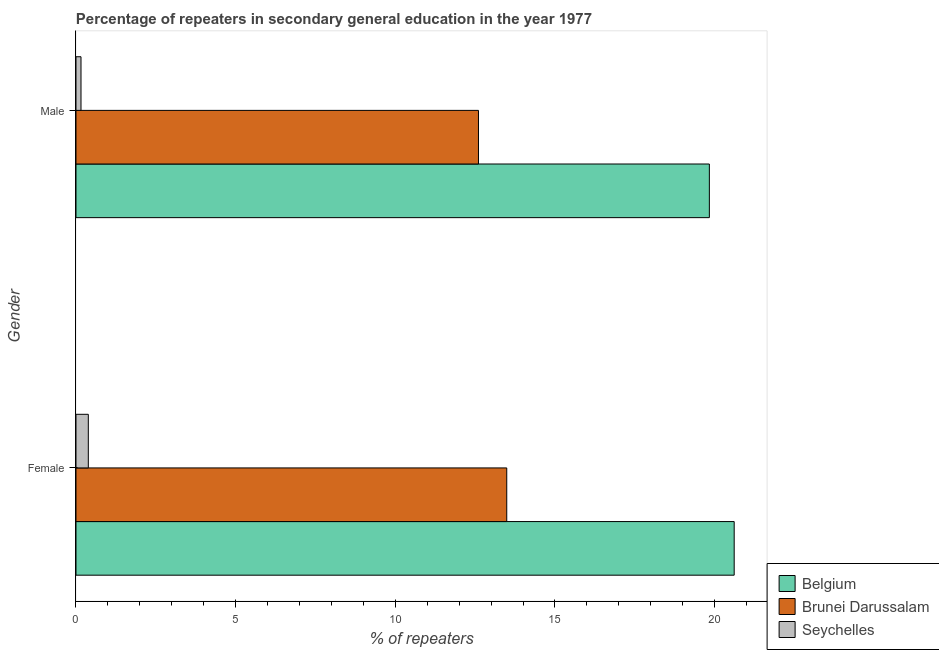How many groups of bars are there?
Your answer should be very brief. 2. Are the number of bars on each tick of the Y-axis equal?
Offer a terse response. Yes. How many bars are there on the 2nd tick from the top?
Ensure brevity in your answer.  3. How many bars are there on the 1st tick from the bottom?
Your answer should be compact. 3. What is the label of the 2nd group of bars from the top?
Offer a terse response. Female. What is the percentage of female repeaters in Belgium?
Offer a very short reply. 20.61. Across all countries, what is the maximum percentage of female repeaters?
Your answer should be very brief. 20.61. Across all countries, what is the minimum percentage of male repeaters?
Your answer should be compact. 0.16. In which country was the percentage of female repeaters maximum?
Give a very brief answer. Belgium. In which country was the percentage of female repeaters minimum?
Your response must be concise. Seychelles. What is the total percentage of male repeaters in the graph?
Provide a short and direct response. 32.6. What is the difference between the percentage of female repeaters in Seychelles and that in Brunei Darussalam?
Give a very brief answer. -13.1. What is the difference between the percentage of male repeaters in Seychelles and the percentage of female repeaters in Brunei Darussalam?
Offer a terse response. -13.33. What is the average percentage of male repeaters per country?
Give a very brief answer. 10.87. What is the difference between the percentage of male repeaters and percentage of female repeaters in Belgium?
Give a very brief answer. -0.78. In how many countries, is the percentage of male repeaters greater than 1 %?
Your answer should be compact. 2. What is the ratio of the percentage of female repeaters in Belgium to that in Seychelles?
Your response must be concise. 53.41. Is the percentage of male repeaters in Seychelles less than that in Brunei Darussalam?
Your answer should be compact. Yes. In how many countries, is the percentage of male repeaters greater than the average percentage of male repeaters taken over all countries?
Your response must be concise. 2. What does the 2nd bar from the top in Female represents?
Your answer should be very brief. Brunei Darussalam. What does the 3rd bar from the bottom in Male represents?
Ensure brevity in your answer.  Seychelles. How many bars are there?
Give a very brief answer. 6. Are all the bars in the graph horizontal?
Your answer should be compact. Yes. How many countries are there in the graph?
Offer a terse response. 3. Does the graph contain any zero values?
Your answer should be very brief. No. Does the graph contain grids?
Your answer should be compact. No. Where does the legend appear in the graph?
Keep it short and to the point. Bottom right. How many legend labels are there?
Your response must be concise. 3. What is the title of the graph?
Provide a short and direct response. Percentage of repeaters in secondary general education in the year 1977. Does "Greenland" appear as one of the legend labels in the graph?
Make the answer very short. No. What is the label or title of the X-axis?
Provide a short and direct response. % of repeaters. What is the label or title of the Y-axis?
Offer a terse response. Gender. What is the % of repeaters in Belgium in Female?
Make the answer very short. 20.61. What is the % of repeaters in Brunei Darussalam in Female?
Provide a short and direct response. 13.49. What is the % of repeaters of Seychelles in Female?
Provide a succinct answer. 0.39. What is the % of repeaters in Belgium in Male?
Your answer should be very brief. 19.83. What is the % of repeaters in Brunei Darussalam in Male?
Give a very brief answer. 12.6. What is the % of repeaters in Seychelles in Male?
Your answer should be compact. 0.16. Across all Gender, what is the maximum % of repeaters of Belgium?
Ensure brevity in your answer.  20.61. Across all Gender, what is the maximum % of repeaters of Brunei Darussalam?
Ensure brevity in your answer.  13.49. Across all Gender, what is the maximum % of repeaters of Seychelles?
Make the answer very short. 0.39. Across all Gender, what is the minimum % of repeaters of Belgium?
Provide a succinct answer. 19.83. Across all Gender, what is the minimum % of repeaters of Brunei Darussalam?
Make the answer very short. 12.6. Across all Gender, what is the minimum % of repeaters of Seychelles?
Provide a succinct answer. 0.16. What is the total % of repeaters of Belgium in the graph?
Offer a very short reply. 40.45. What is the total % of repeaters of Brunei Darussalam in the graph?
Your answer should be compact. 26.09. What is the total % of repeaters of Seychelles in the graph?
Ensure brevity in your answer.  0.54. What is the difference between the % of repeaters in Belgium in Female and that in Male?
Make the answer very short. 0.78. What is the difference between the % of repeaters of Brunei Darussalam in Female and that in Male?
Offer a terse response. 0.89. What is the difference between the % of repeaters of Seychelles in Female and that in Male?
Provide a succinct answer. 0.23. What is the difference between the % of repeaters in Belgium in Female and the % of repeaters in Brunei Darussalam in Male?
Your response must be concise. 8.01. What is the difference between the % of repeaters of Belgium in Female and the % of repeaters of Seychelles in Male?
Your answer should be very brief. 20.46. What is the difference between the % of repeaters of Brunei Darussalam in Female and the % of repeaters of Seychelles in Male?
Ensure brevity in your answer.  13.33. What is the average % of repeaters of Belgium per Gender?
Give a very brief answer. 20.22. What is the average % of repeaters of Brunei Darussalam per Gender?
Offer a very short reply. 13.05. What is the average % of repeaters in Seychelles per Gender?
Your answer should be very brief. 0.27. What is the difference between the % of repeaters of Belgium and % of repeaters of Brunei Darussalam in Female?
Offer a terse response. 7.12. What is the difference between the % of repeaters in Belgium and % of repeaters in Seychelles in Female?
Make the answer very short. 20.23. What is the difference between the % of repeaters in Brunei Darussalam and % of repeaters in Seychelles in Female?
Make the answer very short. 13.1. What is the difference between the % of repeaters in Belgium and % of repeaters in Brunei Darussalam in Male?
Offer a terse response. 7.23. What is the difference between the % of repeaters of Belgium and % of repeaters of Seychelles in Male?
Your answer should be compact. 19.68. What is the difference between the % of repeaters in Brunei Darussalam and % of repeaters in Seychelles in Male?
Provide a succinct answer. 12.45. What is the ratio of the % of repeaters in Belgium in Female to that in Male?
Provide a succinct answer. 1.04. What is the ratio of the % of repeaters in Brunei Darussalam in Female to that in Male?
Your answer should be compact. 1.07. What is the ratio of the % of repeaters of Seychelles in Female to that in Male?
Provide a short and direct response. 2.46. What is the difference between the highest and the second highest % of repeaters in Belgium?
Keep it short and to the point. 0.78. What is the difference between the highest and the second highest % of repeaters in Brunei Darussalam?
Keep it short and to the point. 0.89. What is the difference between the highest and the second highest % of repeaters of Seychelles?
Your response must be concise. 0.23. What is the difference between the highest and the lowest % of repeaters in Belgium?
Provide a short and direct response. 0.78. What is the difference between the highest and the lowest % of repeaters in Brunei Darussalam?
Your response must be concise. 0.89. What is the difference between the highest and the lowest % of repeaters in Seychelles?
Keep it short and to the point. 0.23. 